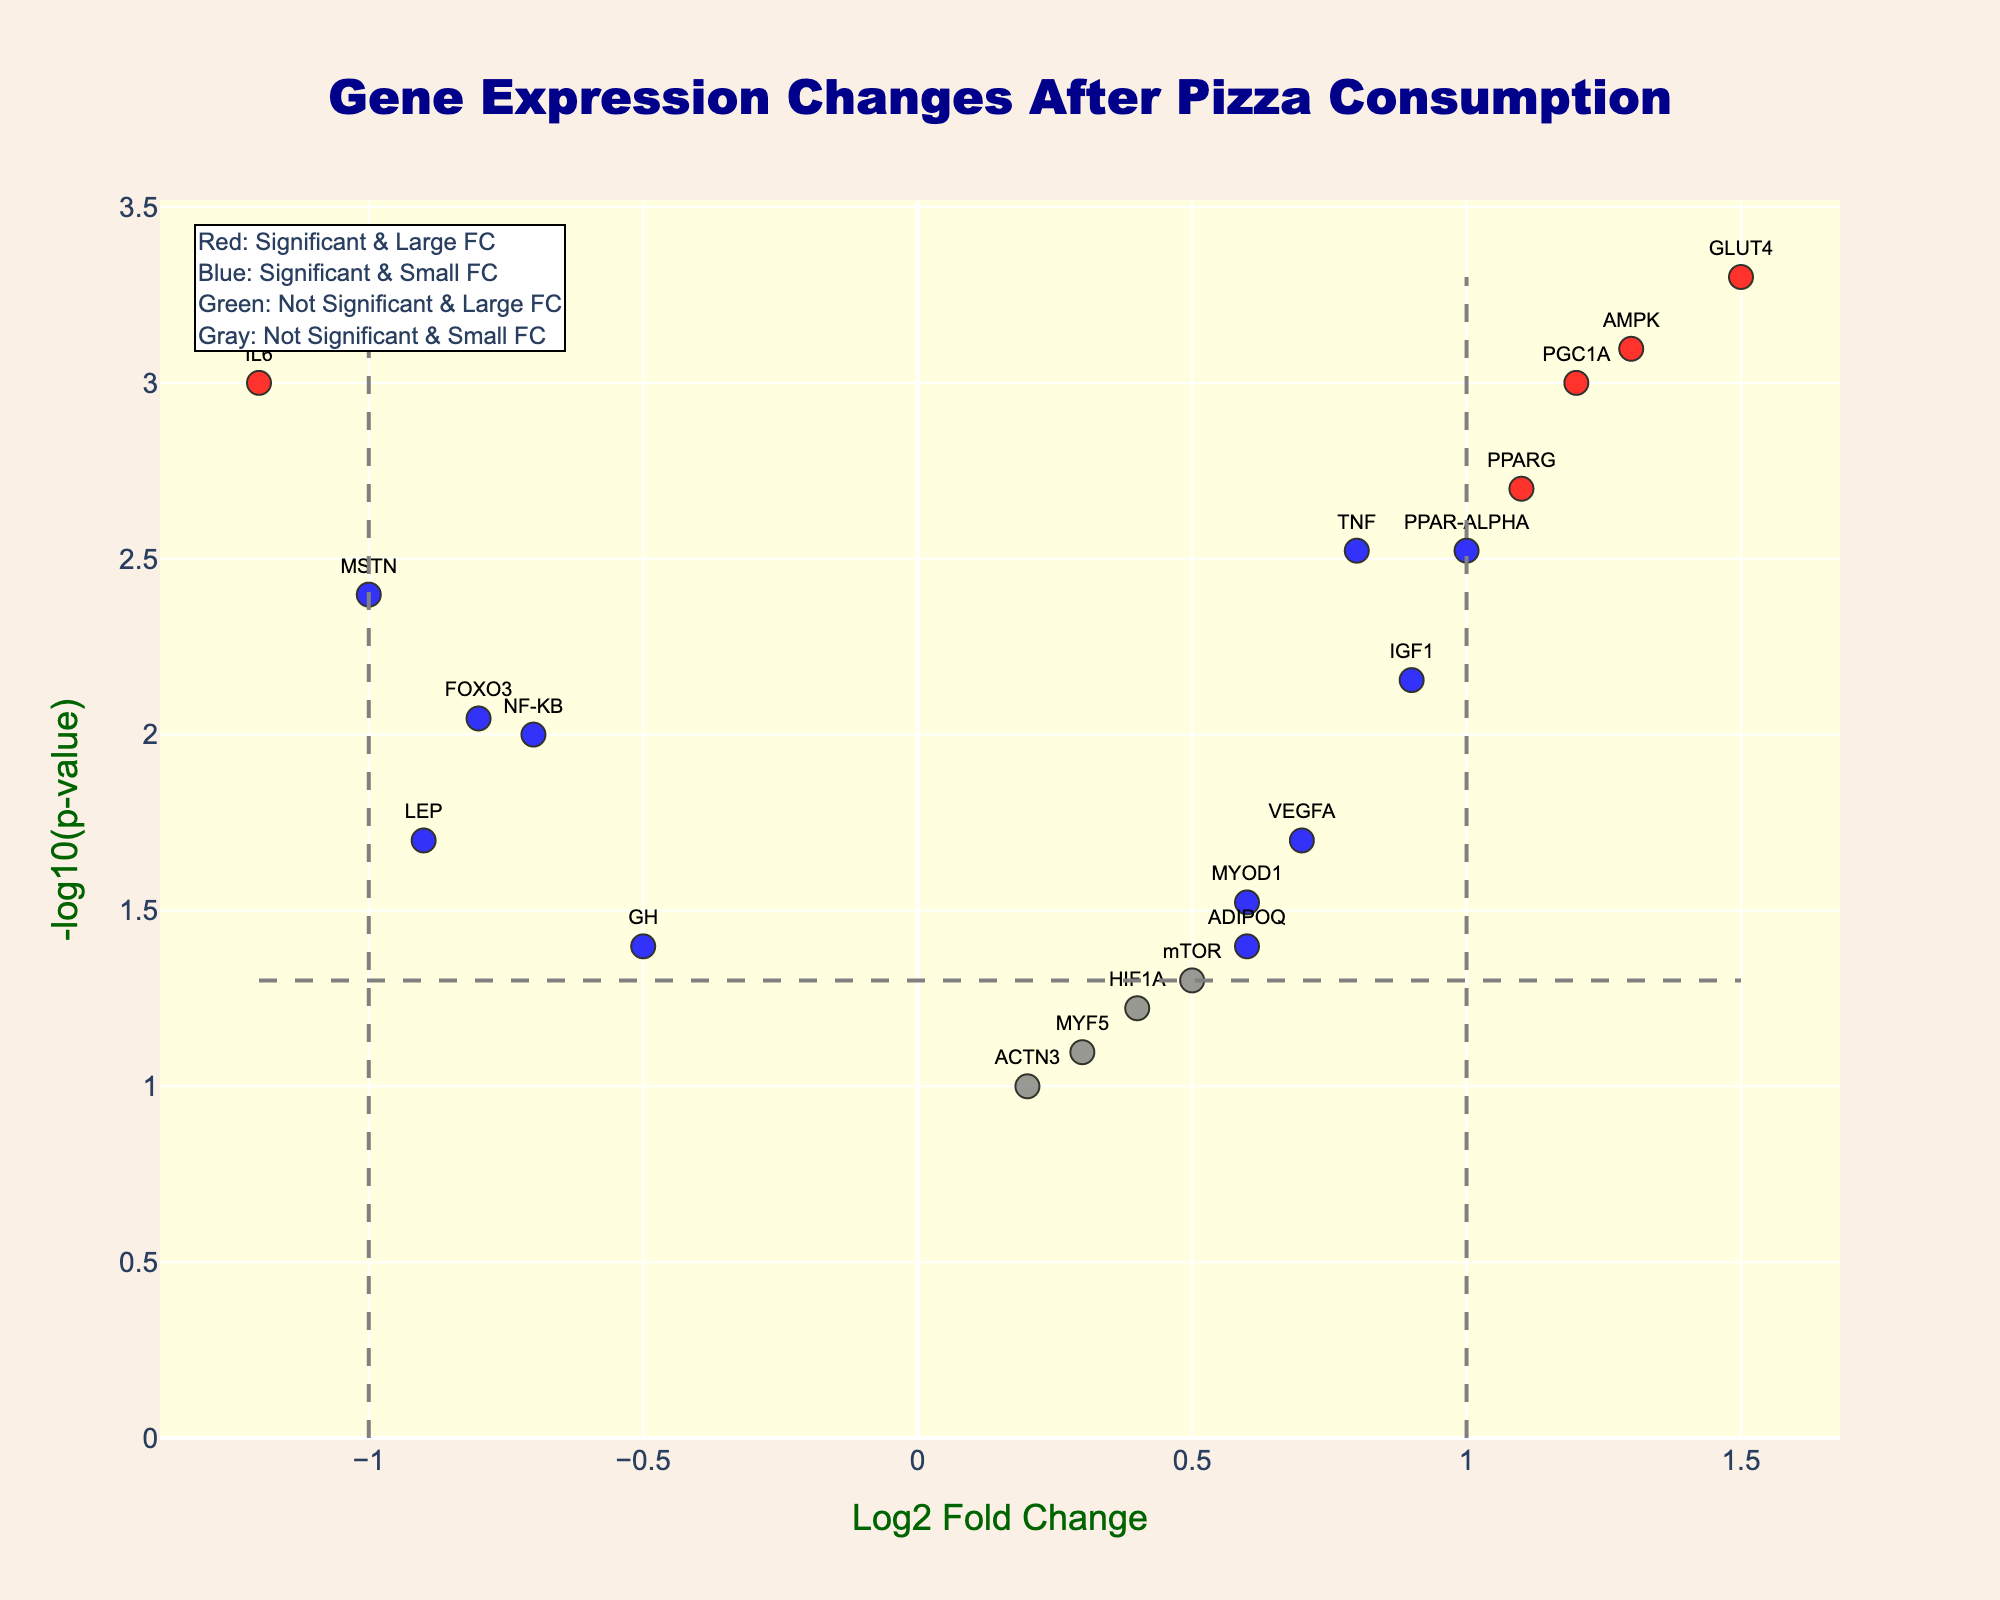What is the title of the figure? The title is typically found at the top of the figure and gives a summary of what the plot represents. In this case, it indicates the context of the gene expression changes.
Answer: Gene Expression Changes After Pizza Consumption What do the x and y axes represent? The x-axis represents the Log2 Fold Change, which measures the change in gene expression levels. The y-axis represents -log10(p-value), which indicates the statistical significance of the changes.
Answer: Log2 Fold Change and -log10(p-value) Which gene has the highest -log10(p-value)? By looking at the y-axis and identifying the point that reaches the highest value, we can see which gene it represents.
Answer: GLUT4 How many genes are marked with red dots in the plot? Red dots indicate genes with significant and large fold changes. We count the number of red dots visible on the plot.
Answer: 6 Which gene has the largest positive Log2 Fold Change? The x-axis shows Log2 Fold Change. To find the largest positive value, look at the furthest right red, blue, or green dot.
Answer: GLUT4 Which gene has the smallest (most negative) Log2 Fold Change and was it statistically significant? To find the smallest Log2 Fold Change, look at the furthest left red, blue, or green dot. Then check if the dot is not gray to determine statistical significance.
Answer: IL6, Yes Are there any genes with a Log2 Fold Change around zero but still significant? A Log2 Fold Change around zero means it's close to the y-axis, and significance is marked with red or blue color. We identify such points.
Answer: Yes, GH and ADIPOQ Which genes have a significant but small fold change? Significant but small fold changes are indicated by blue dots. We list the names of these genes from the blue dots.
Answer: TNF, ADIPOQ, IGF1, MYOD1 What do the gray dots represent? The color annotation indicates that gray dots are not significant and have small fold changes.
Answer: Not significant & small fold change Which gene has the highest p-value? The lowest -log10(p-value) value corresponds to the highest p-value. We find the dot that is closest to zero on the y-axis and note the gene.
Answer: ACTN3 